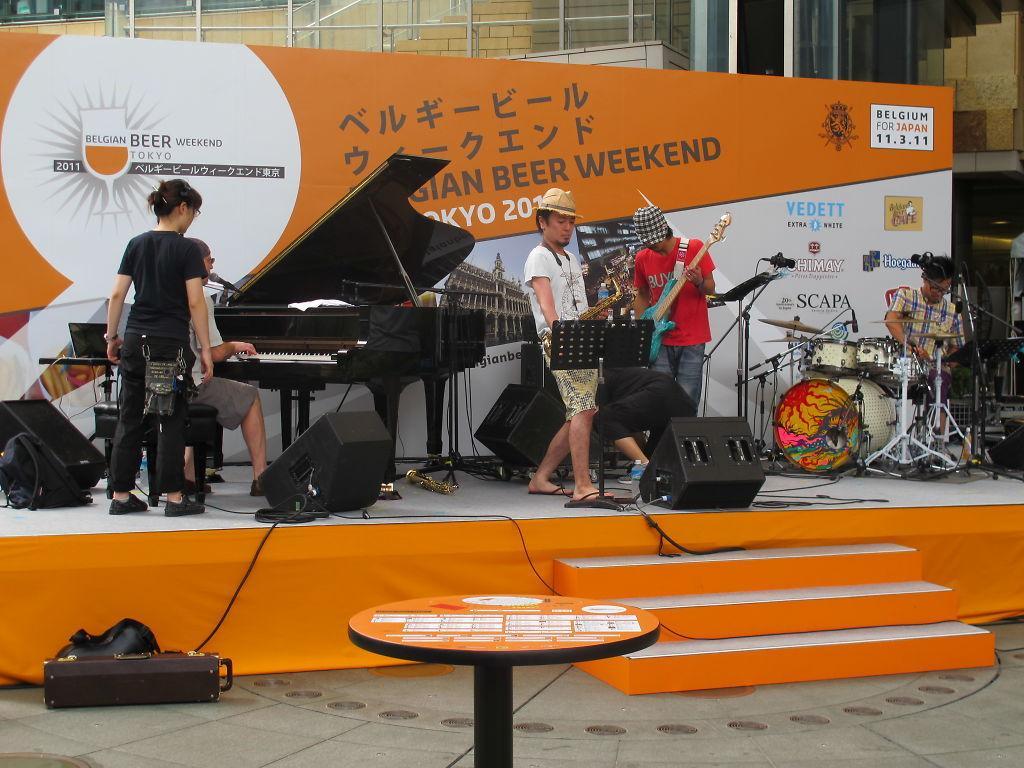How would you summarize this image in a sentence or two? In this picture we can see four men playing musical instrument such as piano, guitars, drums and on stage woman is standing and in front we have steps and in the background we can see banner. 